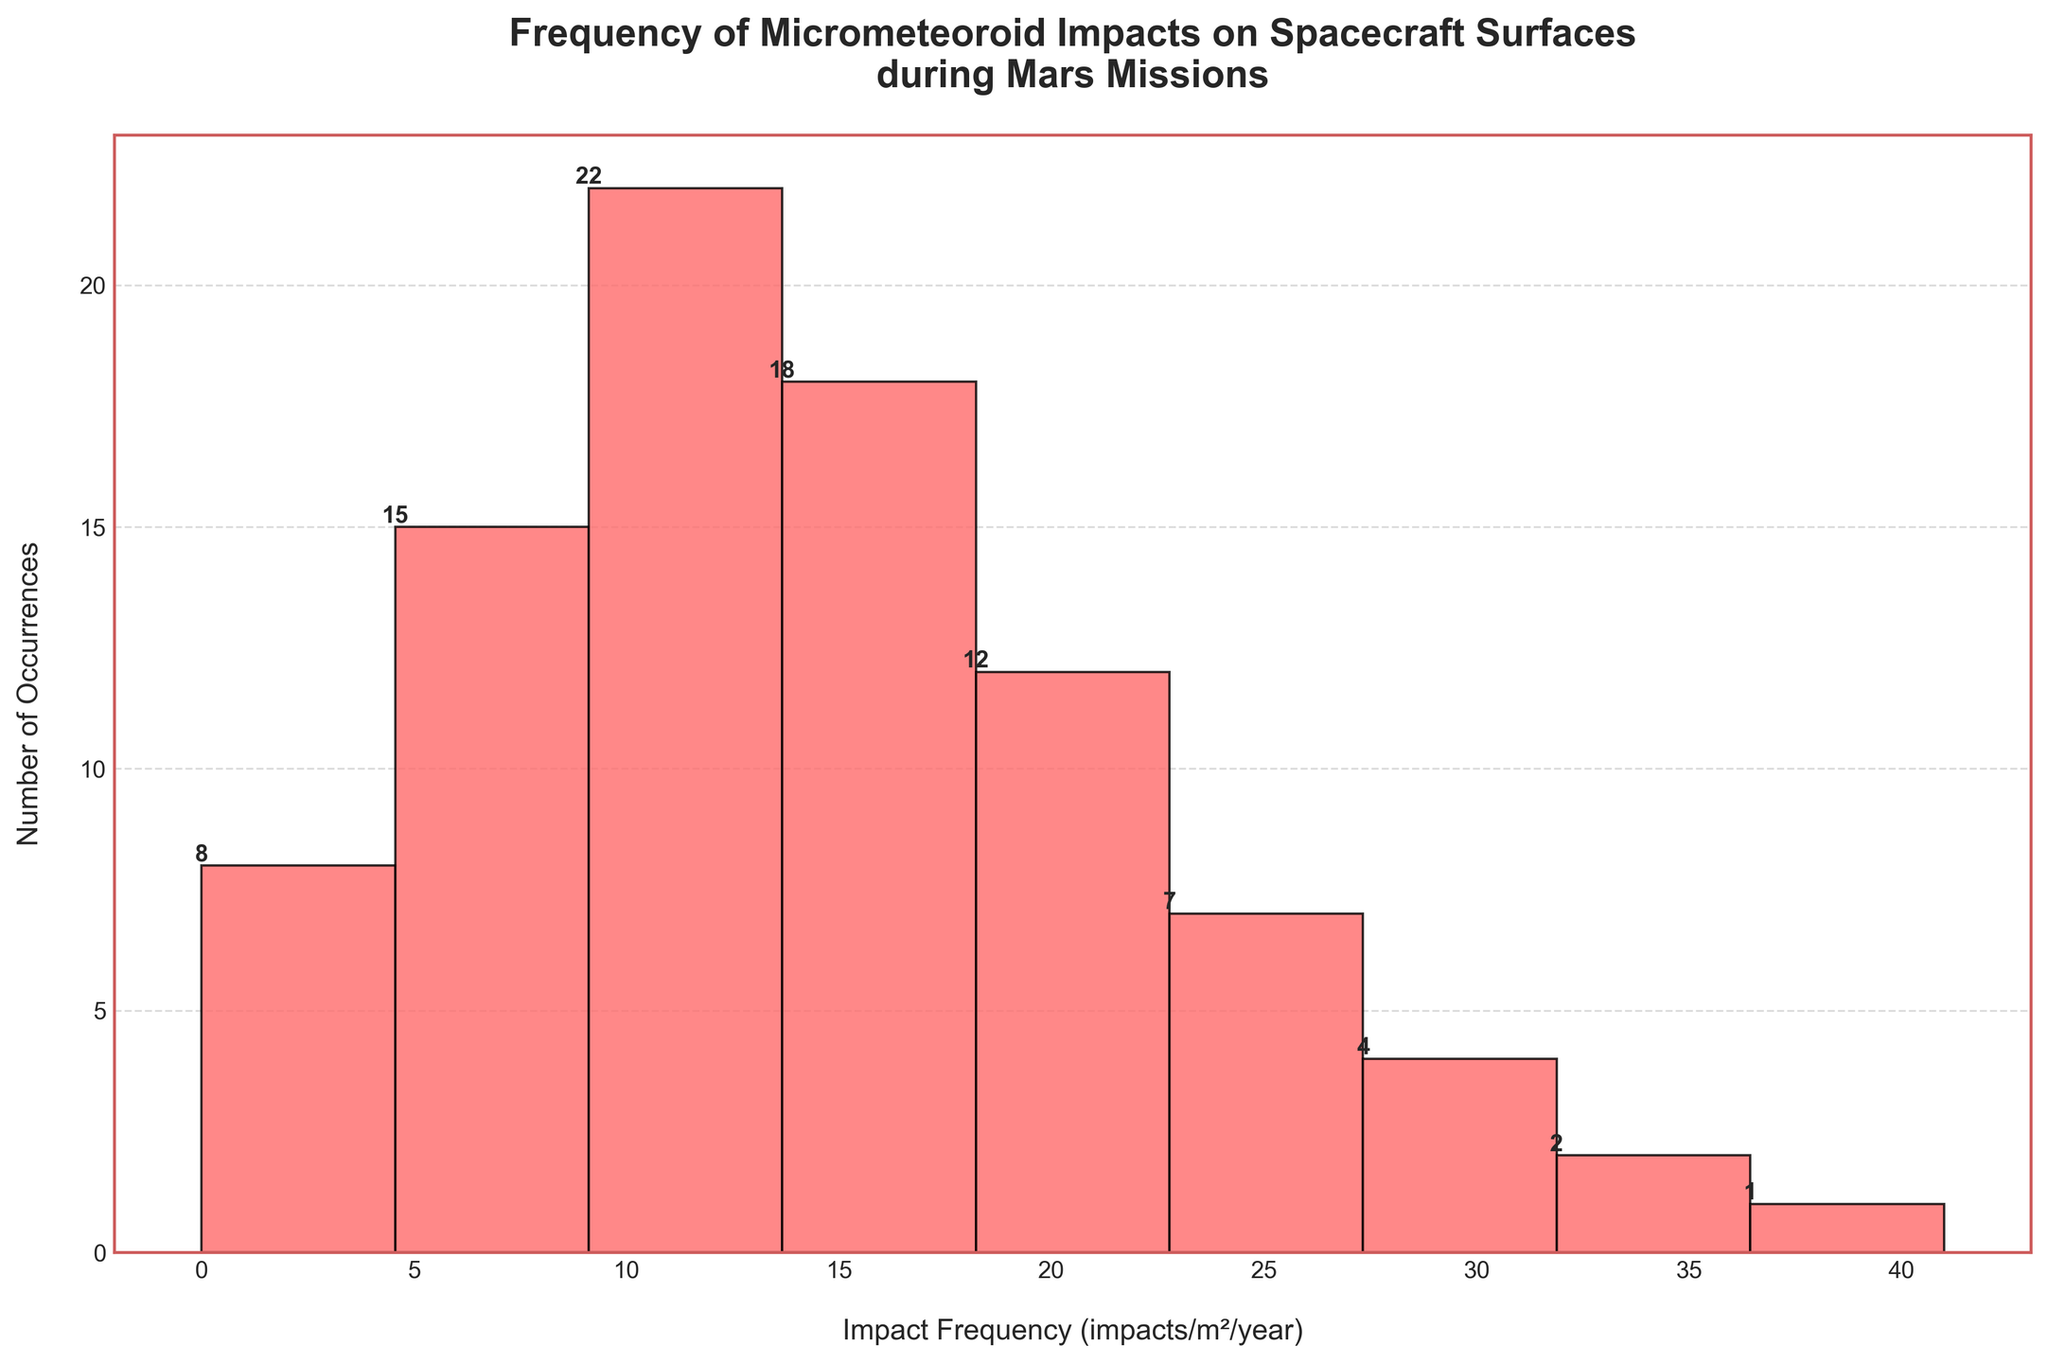What is the highest number of occurrences recorded for any impact frequency range? The bar representing the impact frequency range of 11-15 impacts/m²/year has the highest value. By looking at the figure, we can see it reaches 22 on the y-axis.
Answer: 22 How many impact frequency ranges have more than 15 occurrences? By examining the bars and their labels, we can see that two ranges (11-15 impacts/m²/year and 16-20 impacts/m²/year) have more than 15 occurrences.
Answer: 2 What is the total number of occurrences reported? Add the occurrences of all impact frequency ranges given in the dataset: 8 + 15 + 22 + 18 + 12 + 7 + 4 + 2 + 1. The sum is 89.
Answer: 89 Which impact frequency range has the least number of occurrences? The shortest bar on the histogram, corresponding to the 41-45 impacts/m²/year range, represents the fewest occurrences, which is 1.
Answer: 41-45 impacts/m²/year How many impact frequency ranges recorded less than 10 occurrences? Check all the bars and count those with less than 10 occurrences. They are: 0-5, 26-30, 31-35, 36-40, and 41-45 impacts/m²/year. This gives us a total of 5 ranges.
Answer: 5 What is the combined total occurrences for the frequency ranges between 6-20 impacts/m²/year? Sum the occurrences for the ranges 6-10, 11-15, and 16-20: 15 + 22 + 18, which equals 55.
Answer: 55 By how much do the occurrences of the 11-15 impacts/m²/year range exceed the occurrences of the 0-5 impacts/m²/year range? Subtract the number of occurrences for 0-5 impacts/m²/year from that of 11-15: 22 - 8 = 14.
Answer: 14 What is the median number of occurrences across all impact frequency ranges? First, list the occurrences in ascending order: 1, 2, 4, 7, 8, 12, 15, 18, 22. Since there are 9 data points, the median value is the middle one, which is 12.
Answer: 12 How many impact frequency ranges are there in the figure? Count the number of bars displayed in the histogram, represented by different impact frequency ranges, which is 9.
Answer: 9 